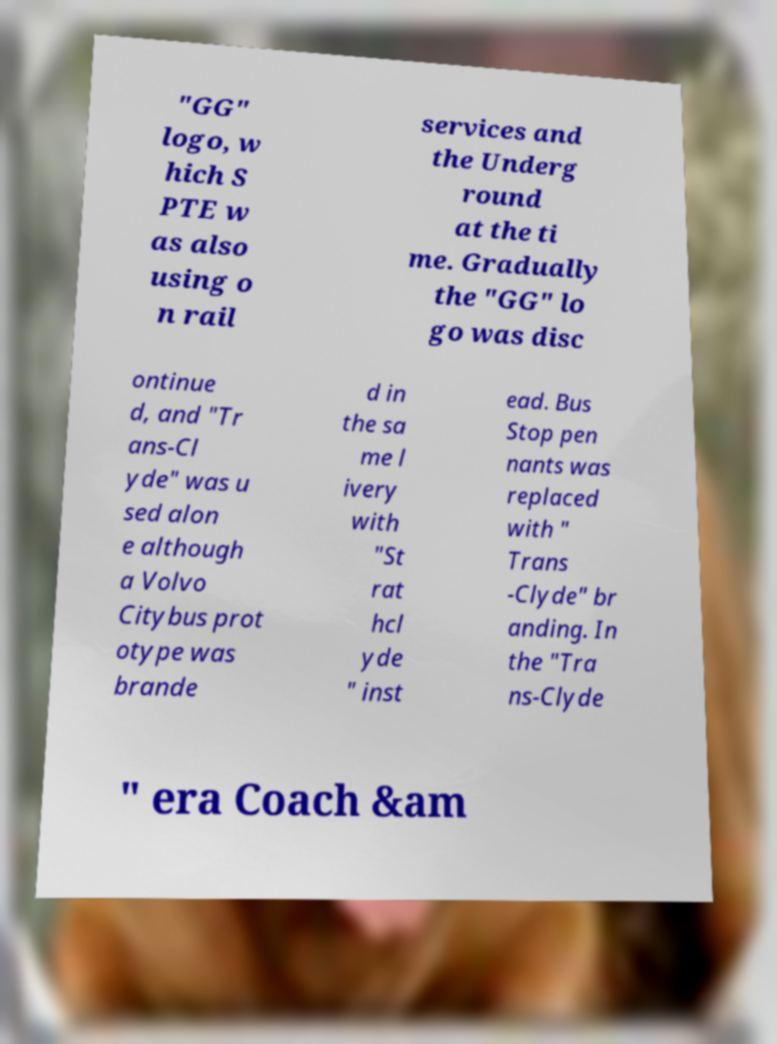There's text embedded in this image that I need extracted. Can you transcribe it verbatim? "GG" logo, w hich S PTE w as also using o n rail services and the Underg round at the ti me. Gradually the "GG" lo go was disc ontinue d, and "Tr ans-Cl yde" was u sed alon e although a Volvo Citybus prot otype was brande d in the sa me l ivery with "St rat hcl yde " inst ead. Bus Stop pen nants was replaced with " Trans -Clyde" br anding. In the "Tra ns-Clyde " era Coach &am 